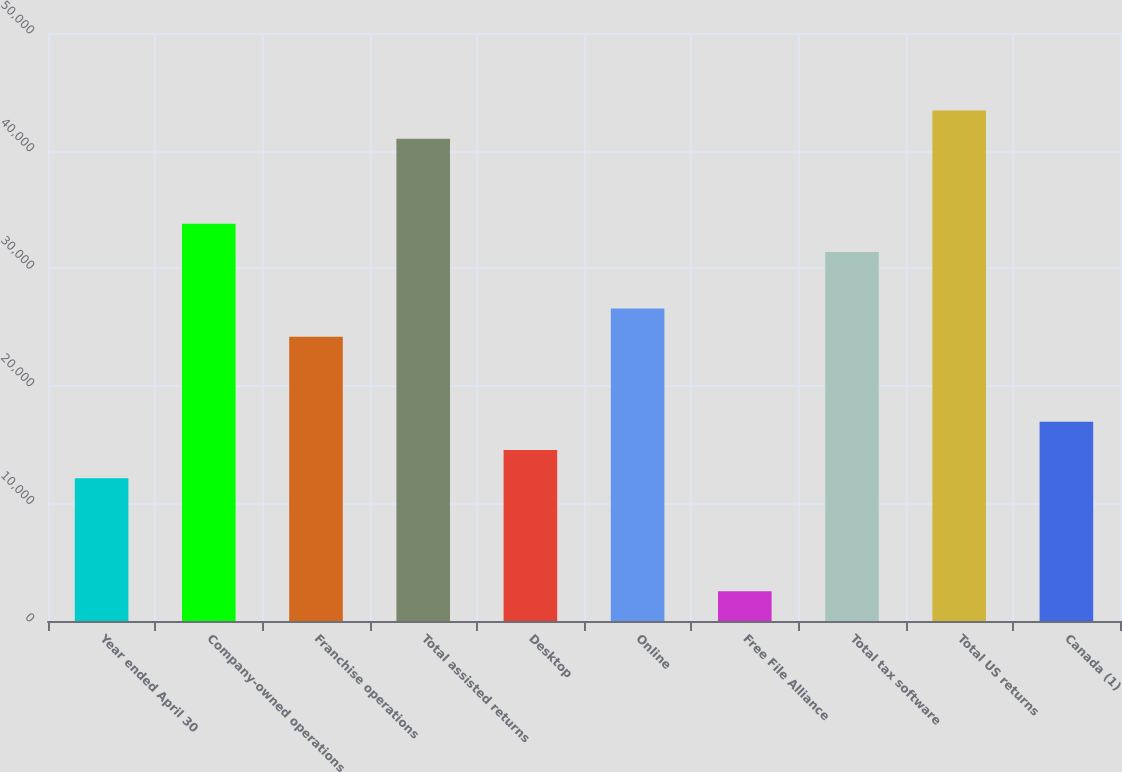Convert chart. <chart><loc_0><loc_0><loc_500><loc_500><bar_chart><fcel>Year ended April 30<fcel>Company-owned operations<fcel>Franchise operations<fcel>Total assisted returns<fcel>Desktop<fcel>Online<fcel>Free File Alliance<fcel>Total tax software<fcel>Total US returns<fcel>Canada (1)<nl><fcel>12140<fcel>33785<fcel>24165<fcel>41000<fcel>14545<fcel>26570<fcel>2520<fcel>31380<fcel>43405<fcel>16950<nl></chart> 